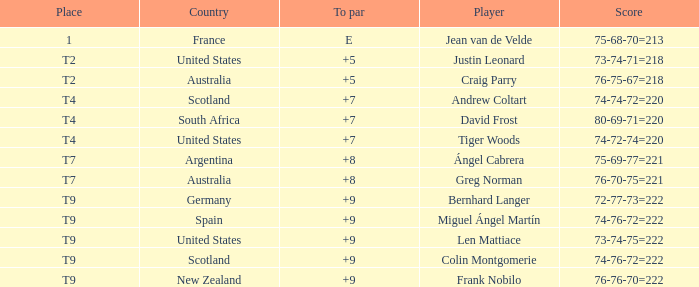Which player from Scotland has a To Par score of +7? Andrew Coltart. 